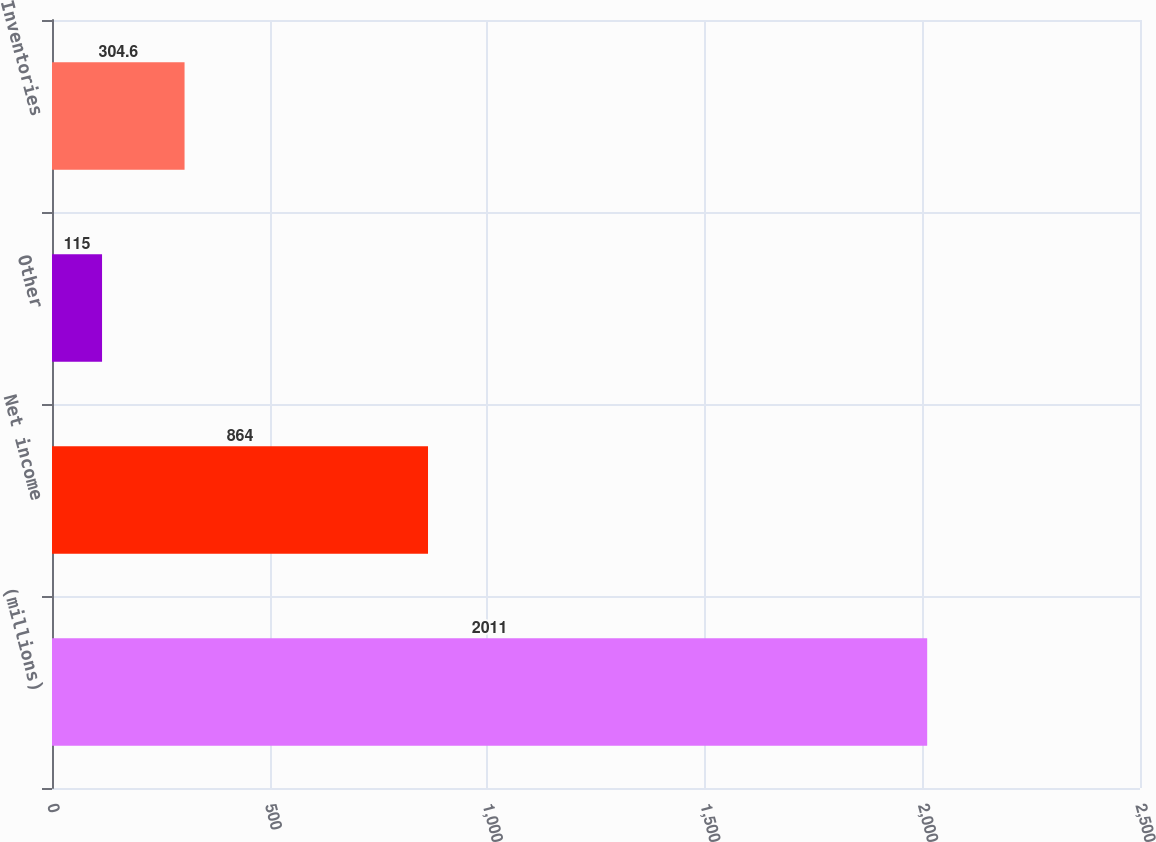Convert chart to OTSL. <chart><loc_0><loc_0><loc_500><loc_500><bar_chart><fcel>(millions)<fcel>Net income<fcel>Other<fcel>Inventories<nl><fcel>2011<fcel>864<fcel>115<fcel>304.6<nl></chart> 